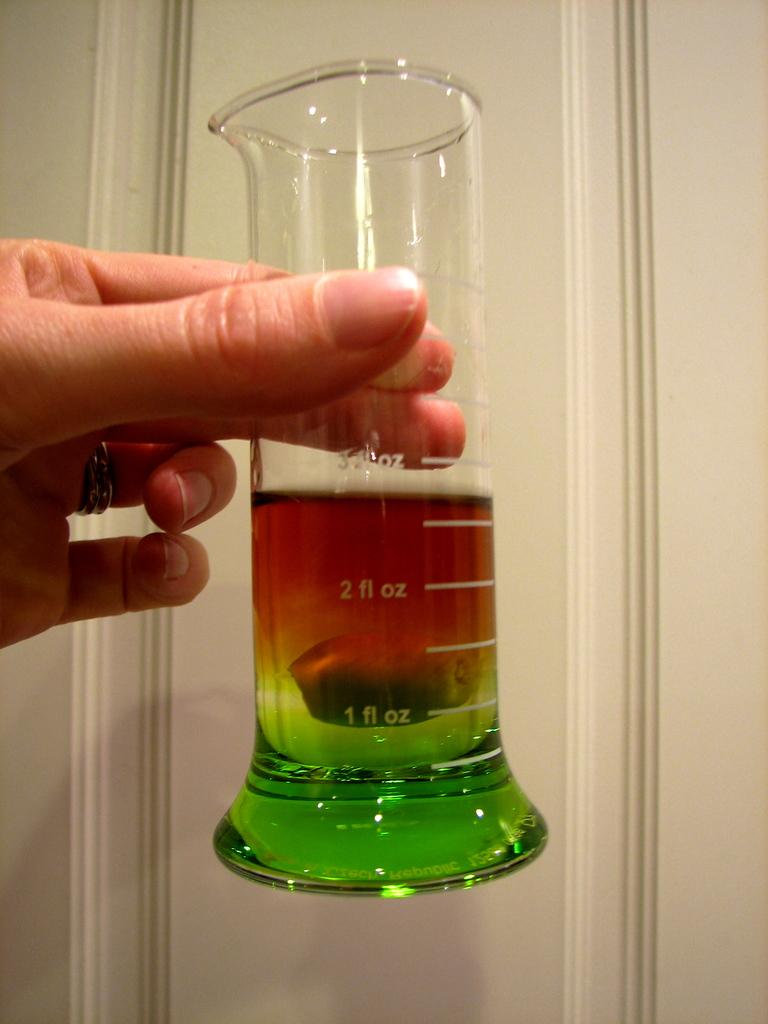<image>
Write a terse but informative summary of the picture. Almost 3 ounces of fluid can be found in the beaker. 